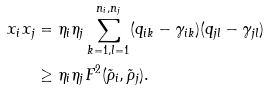<formula> <loc_0><loc_0><loc_500><loc_500>x _ { i } x _ { j } & = \eta _ { i } \eta _ { j } \sum _ { k = 1 , l = 1 } ^ { n _ { i } , n _ { j } } ( q _ { i k } - \gamma _ { i k } ) ( q _ { j l } - \gamma _ { j l } ) \\ & \geq \eta _ { i } \eta _ { j } F ^ { 2 } ( \tilde { \rho } _ { i } , \tilde { \rho } _ { j } ) .</formula> 